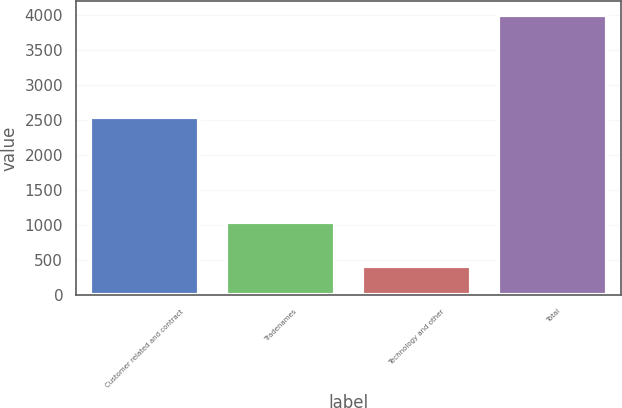<chart> <loc_0><loc_0><loc_500><loc_500><bar_chart><fcel>Customer related and contract<fcel>Tradenames<fcel>Technology and other<fcel>Total<nl><fcel>2550<fcel>1047<fcel>416<fcel>4013<nl></chart> 